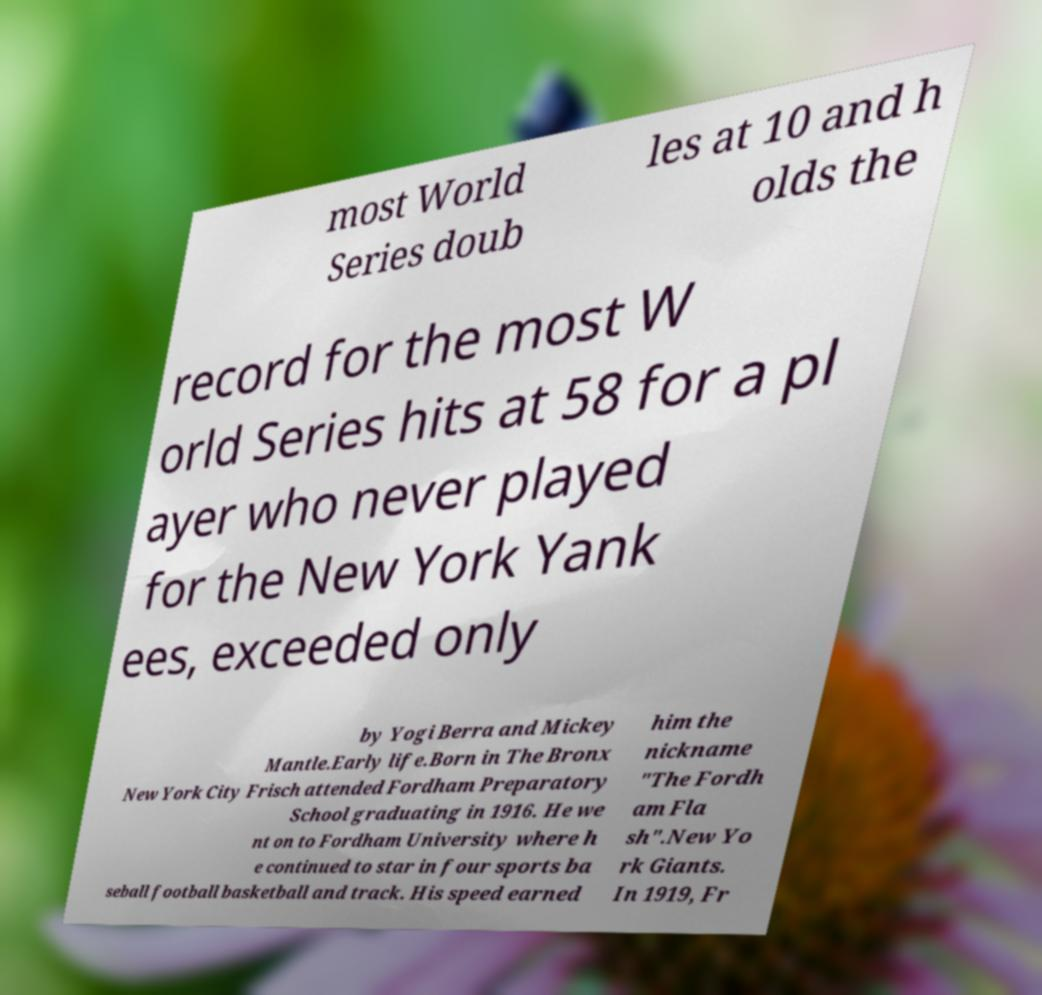Please read and relay the text visible in this image. What does it say? most World Series doub les at 10 and h olds the record for the most W orld Series hits at 58 for a pl ayer who never played for the New York Yank ees, exceeded only by Yogi Berra and Mickey Mantle.Early life.Born in The Bronx New York City Frisch attended Fordham Preparatory School graduating in 1916. He we nt on to Fordham University where h e continued to star in four sports ba seball football basketball and track. His speed earned him the nickname "The Fordh am Fla sh".New Yo rk Giants. In 1919, Fr 